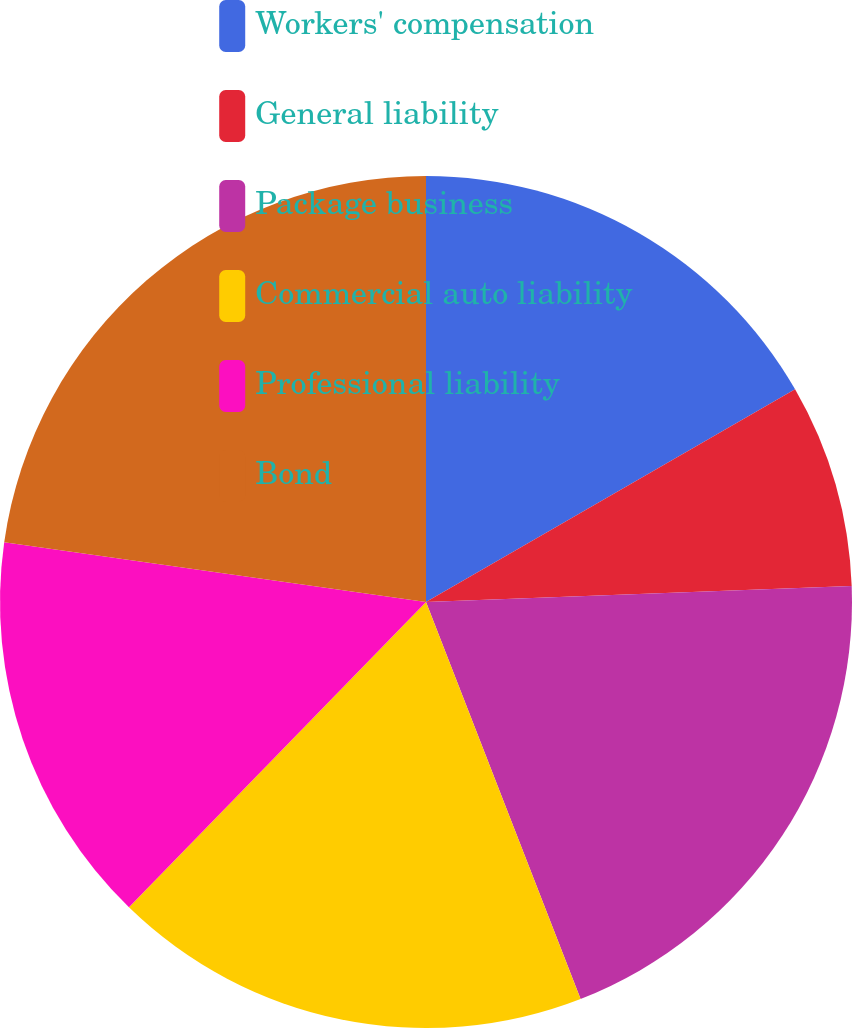Convert chart to OTSL. <chart><loc_0><loc_0><loc_500><loc_500><pie_chart><fcel>Workers' compensation<fcel>General liability<fcel>Package business<fcel>Commercial auto liability<fcel>Professional liability<fcel>Bond<nl><fcel>16.68%<fcel>7.72%<fcel>19.69%<fcel>18.19%<fcel>14.96%<fcel>22.76%<nl></chart> 